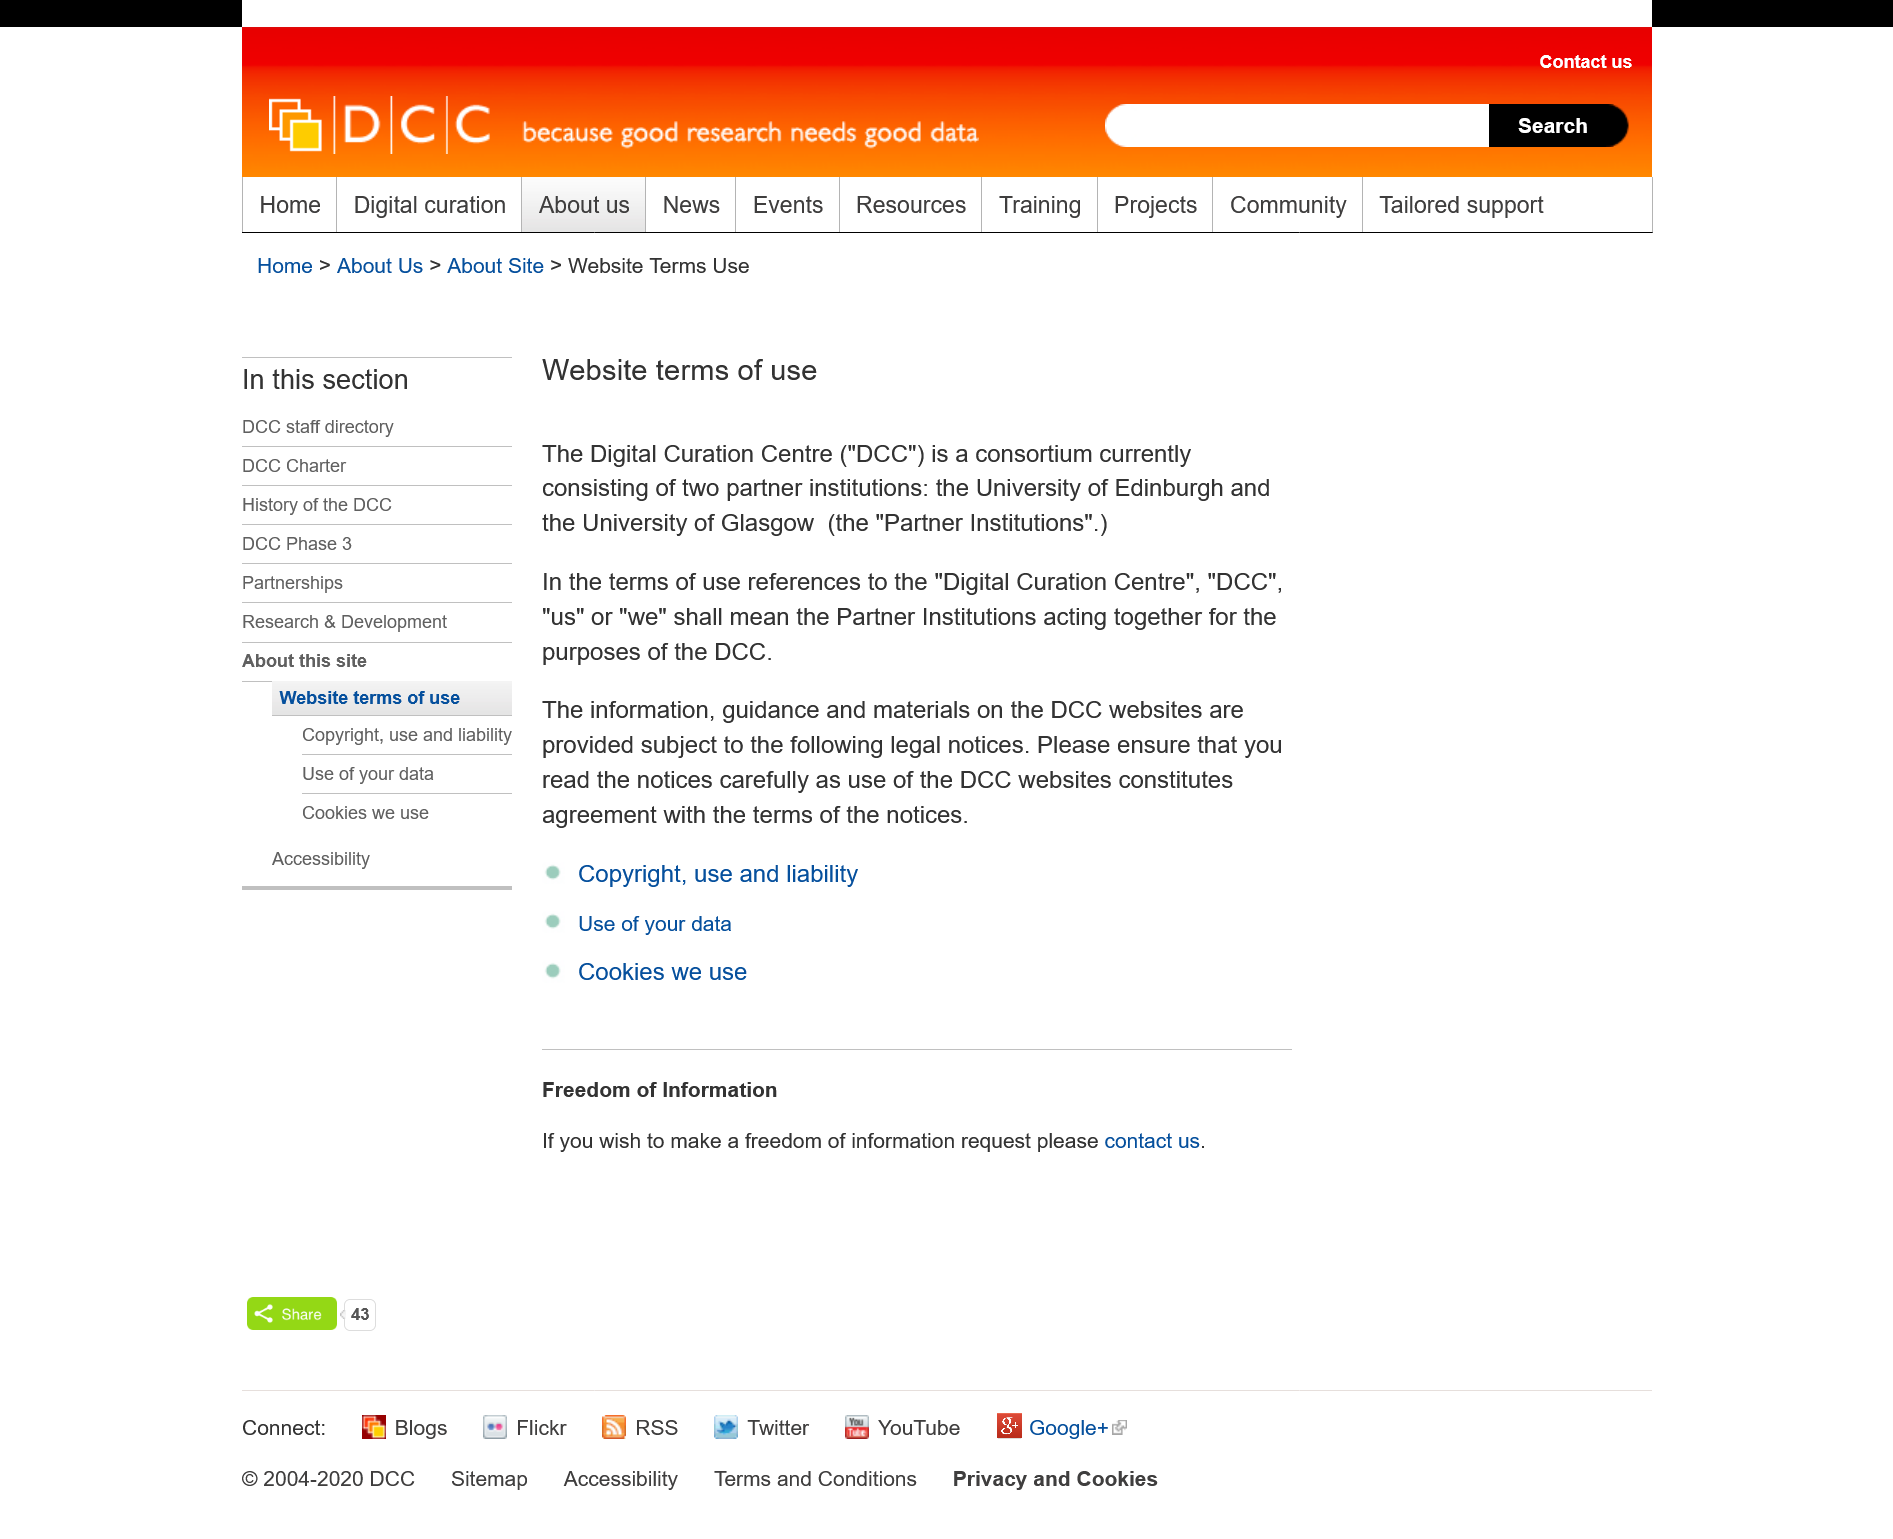Identify some key points in this picture. Digital Curation Centre" is an acronym that stands for "DCC". The Digital Curation Centre is a collaboration between the University of Edinburgh and the University of Glasgow. Using the DCC websites implies acceptance of the terms outlined in its legal notices. 